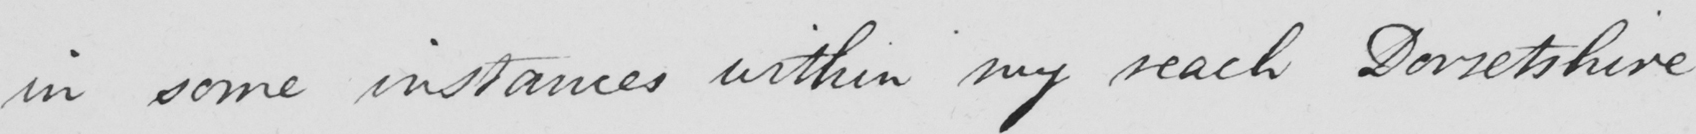What does this handwritten line say? in some instances within my reach Dorsetshire 